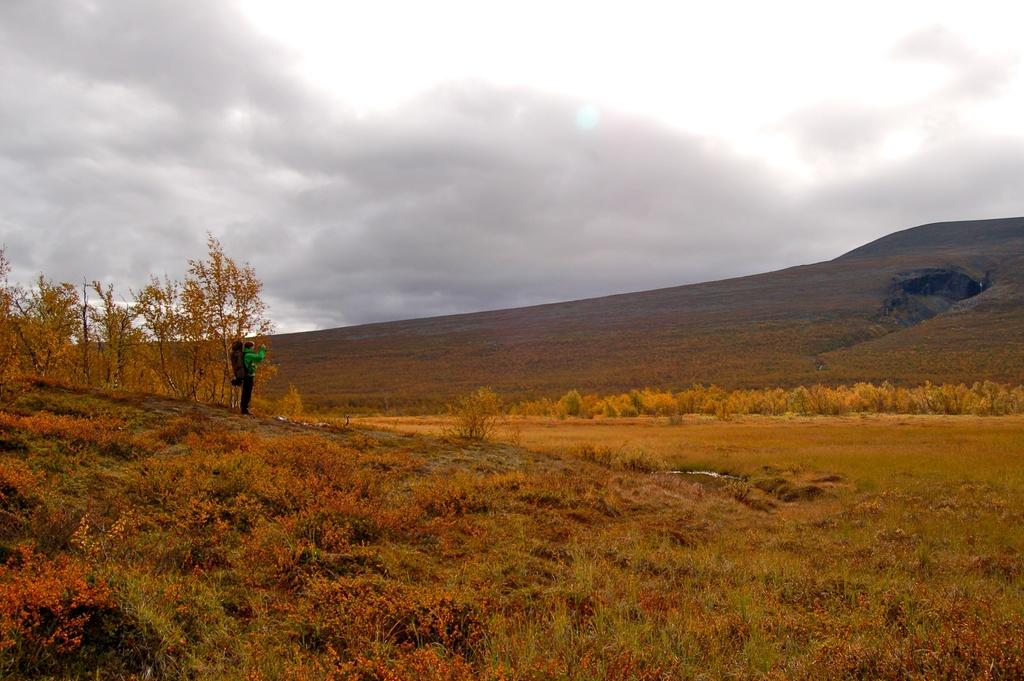What is the main subject of the image? There is a person in the image. What is the person wearing? The person is wearing a bag. What is the person's posture in the image? The person is standing. What type of vegetation can be seen on the ground in the image? There are plants on the ground in the image. What type of natural feature is visible in the background of the image? There is a hill in the background of the image. What is visible in the sky in the image? The sky is visible in the background of the image, and clouds are present. What type of quilt is being used as a prop in the image? There is no quilt present in the image. Can you tell me how many brothers are visible in the image? There is no mention of a brother or any siblings in the image. 